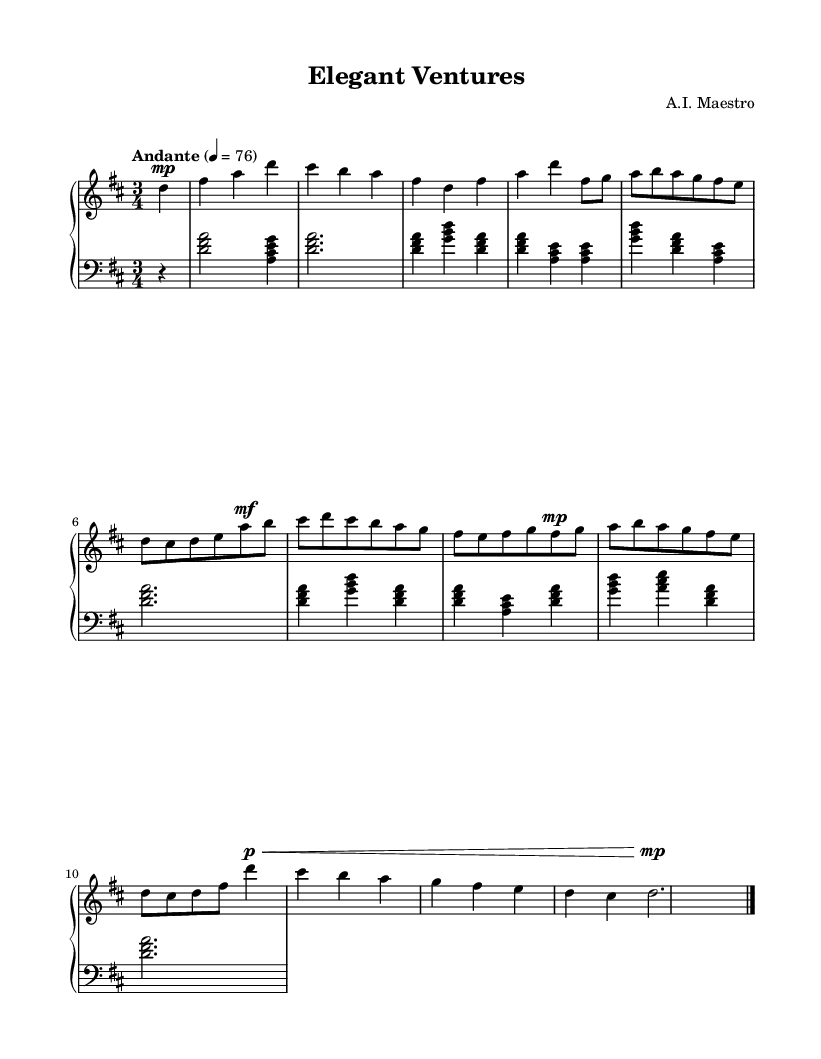What is the key signature of this music? The key signature is indicated by the sharp symbols in the music. Since there are two sharps, it corresponds to D major.
Answer: D major What is the time signature of this piece? The time signature is located at the beginning of the score. It shows three beats per measure, noted as 3/4.
Answer: 3/4 What is the tempo marking for this composition? The tempo marking can be found near the beginning and is expressed as "Andante" with a metronome marking of quarter note equals 76.
Answer: Andante, quarter note = 76 How many sections are present in the piece? By examining the structure, we can identify sections labeled "Introduction," "A," "B," "A'," and "Coda," totaling five distinct sections.
Answer: 5 Which dynamic marking appears at the beginning of the piece? The dynamic marking is found above the first note and indicates the volume to play, which is marked as "mp" (mezzo-piano) for a moderately soft volume.
Answer: mp What is the ending dynamic marking in the Coda section? The Coda includes a dynamic marking of "p" (piano), which suggests a soft ending for the piece. This is followed by a crescendo marked with a hairpin symbol "<".
Answer: p 